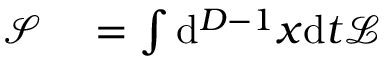Convert formula to latex. <formula><loc_0><loc_0><loc_500><loc_500>\begin{array} { r l } { { \mathcal { S } } } & = \int d ^ { D - 1 } x d t { \mathcal { L } } } \end{array}</formula> 